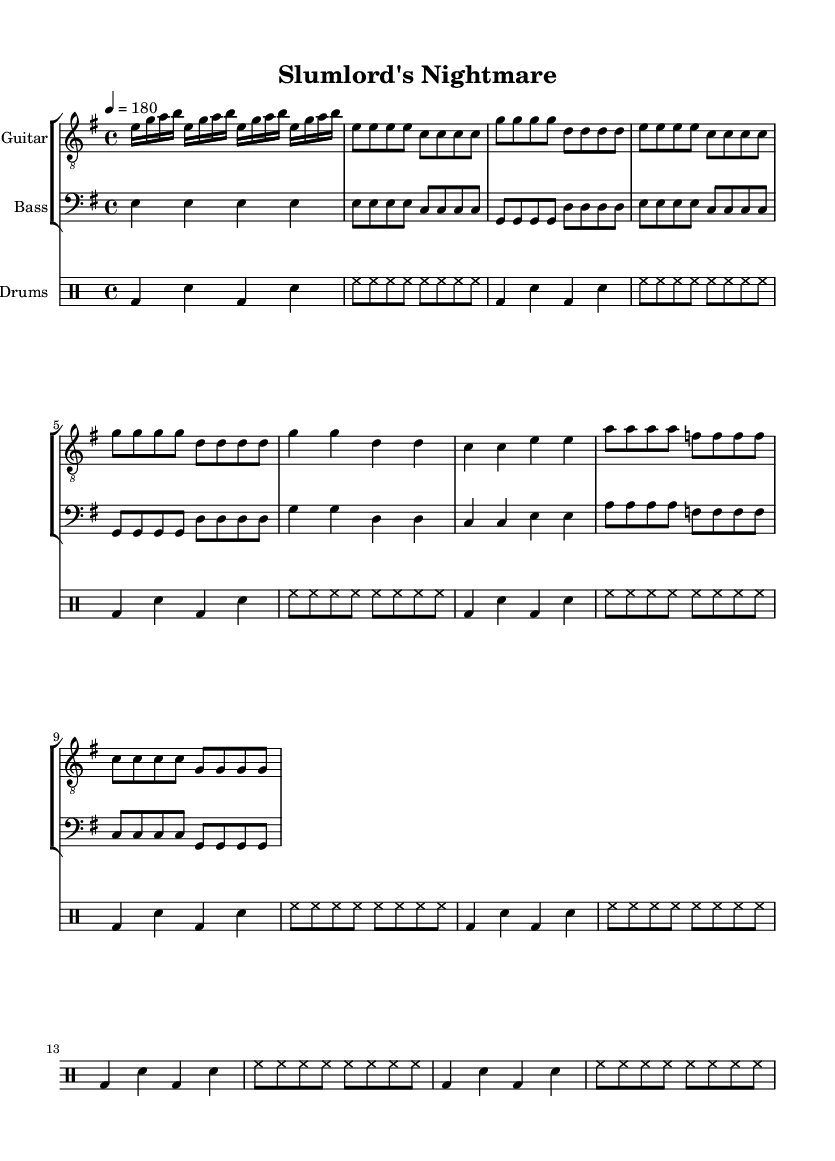What is the tempo of this music? The tempo marking indicates a speed of 180 beats per minute, as specified by the tempo indication in the global section.
Answer: 180 What is the time signature of this music? The time signature appears in the global section and indicates that there are four beats in a measure.
Answer: 4/4 What is the key signature of this music? The key signature is specified in the global section and indicates that the piece is in E minor, which typically has one sharp (F#).
Answer: E minor How many measures are there in the chorus? By examining the chorus section, it consists of a total of four measures formatted as pairs, giving a total of four distinct measures in that part.
Answer: 4 What is the primary instrument featured in the main riff? The main riff is indicated in the electric guitar part, which starts the piece and is played prominently at the start.
Answer: Electric Guitar How many times is the basic rock beat repeated in the drums part? The basic rock beat is found in the drums section where it is indicated to be repeated eight times, which signifies its prominence throughout the piece.
Answer: 8 